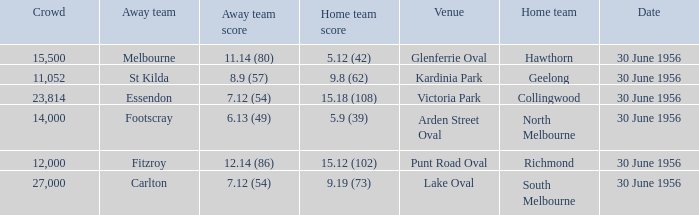What is the home team score when the away team is St Kilda? 9.8 (62). 